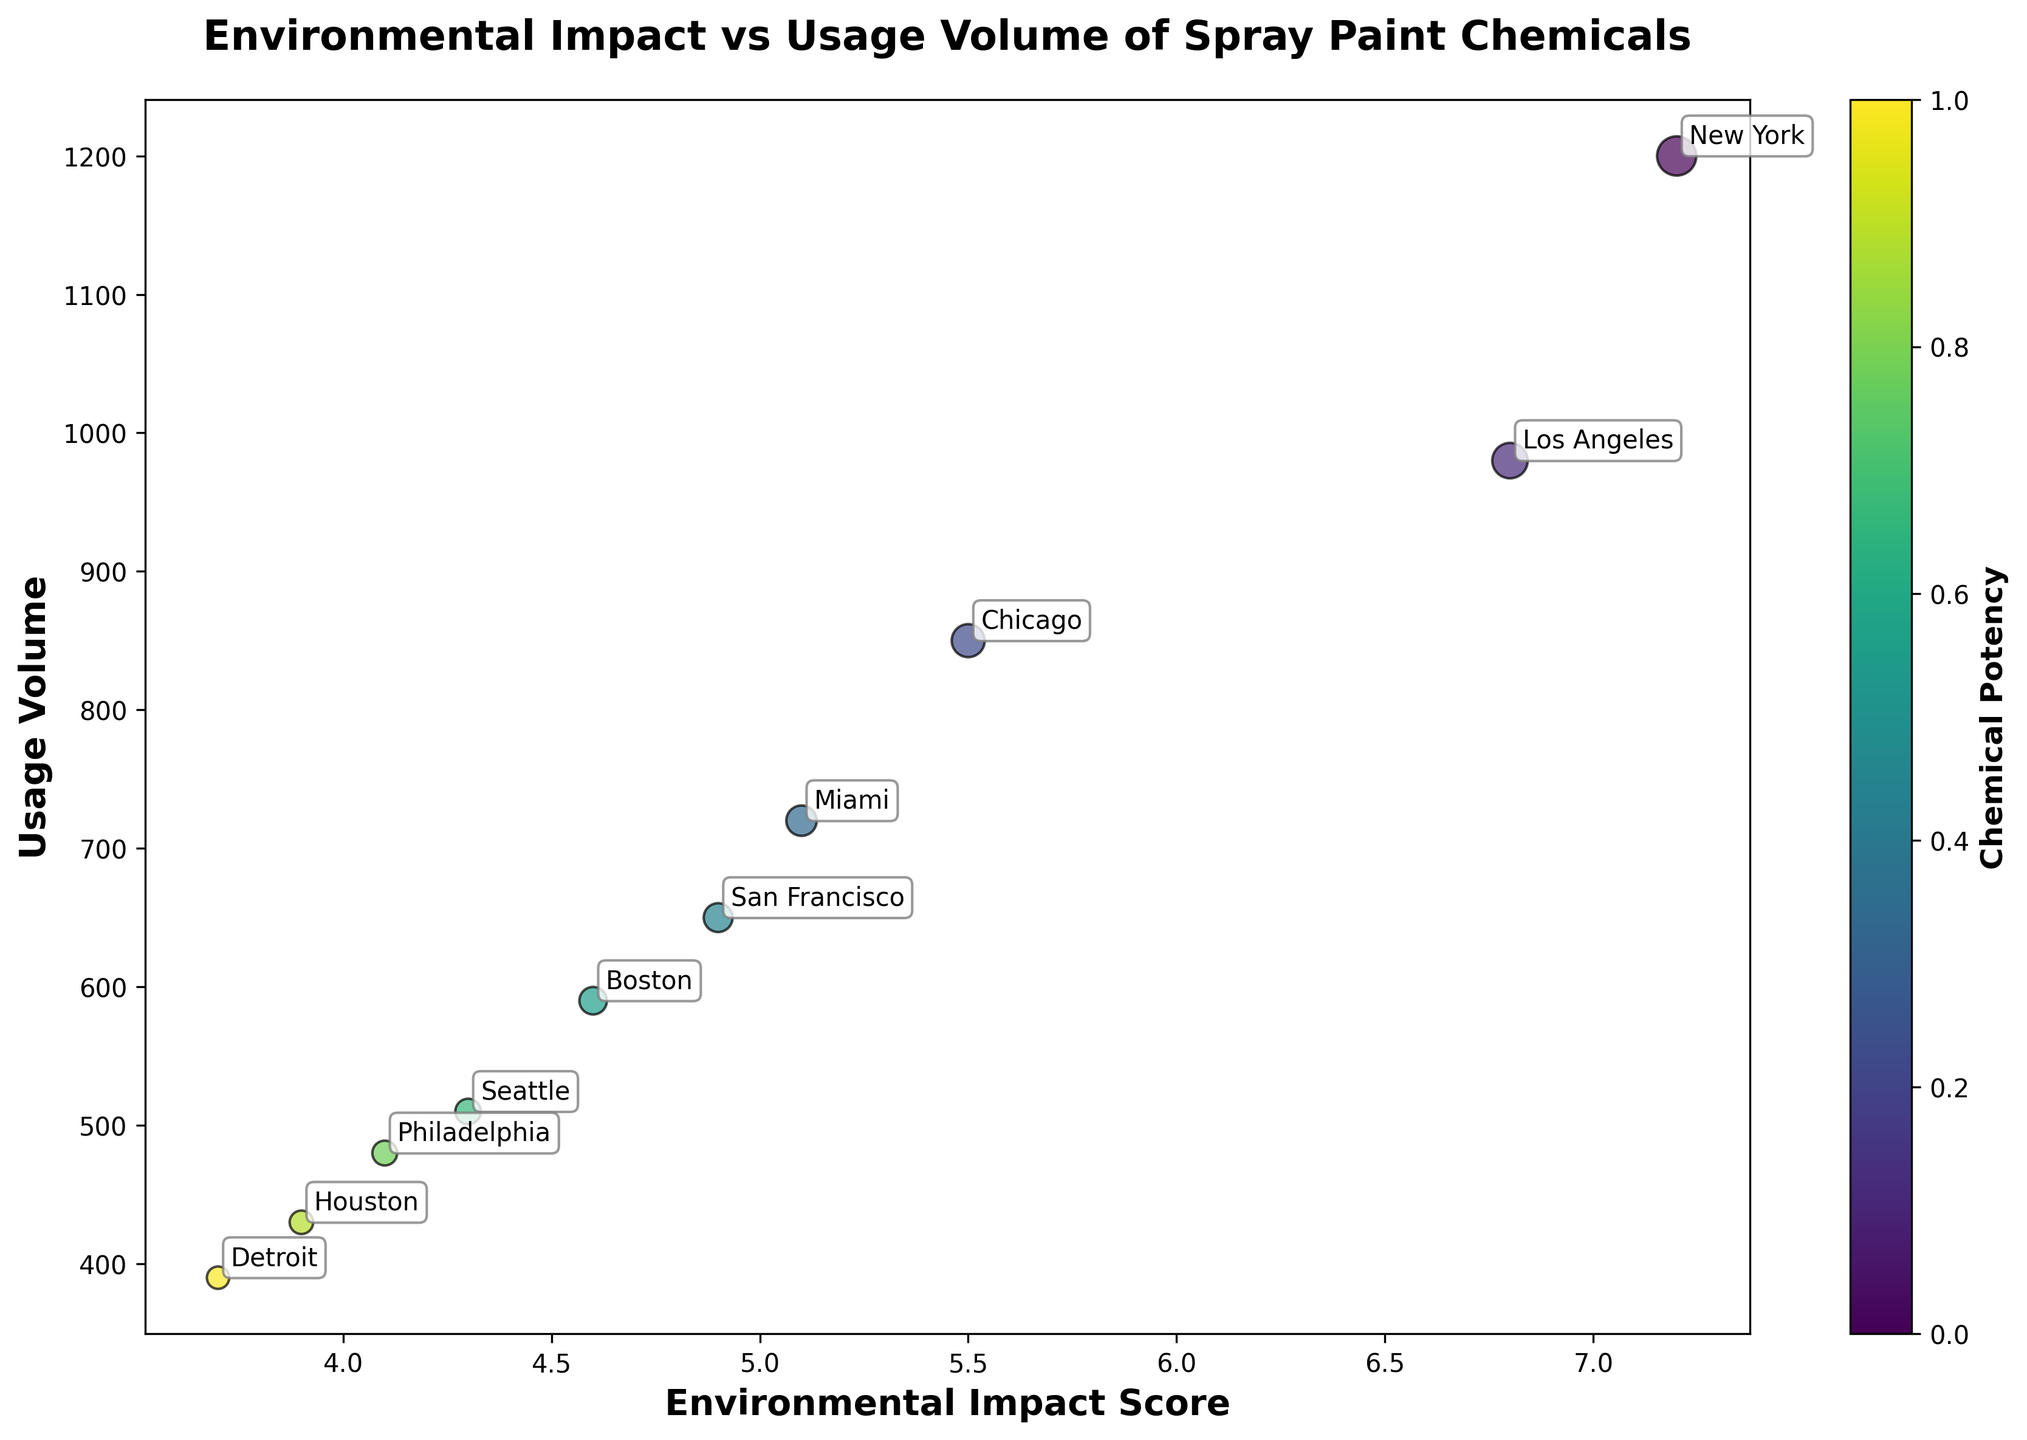What is the relationship between the Environmental Impact Score and Usage Volume shown in the plot? The scatter plot shows the relationship between the Environmental Impact Score and the Usage Volume of various chemicals. By observing the plot, larger bubbles represent higher Usage Volumes, and they tend to cluster around higher Impact Scores, indicating that chemicals with higher usage tend to have higher environmental impacts.
Answer: Positive relationship Which city corresponds to the chemical with the highest Environmental Impact Score? The chemical with the highest Environmental Impact Score appears to have a score of 7.2. From the plot, the bubble with this score is annotated as "New York".
Answer: New York What are the Environmental Impact Scores of the chemicals used in Chicago and Miami? By locating the annotations for "Chicago" and "Miami" and reading the corresponding Environmental Impact Scores from the x-axis, we see that Chicago’s score is 5.5, and Miami’s score is 5.1.
Answer: 5.5 (Chicago), 5.1 (Miami) Which city has the lowest Usage Volume, and what is that volume? The smallest bubble in the plot represents the lowest Usage Volume. The annotation for this bubble is "Detroit", and the volume is 390 (from the y-axis).
Answer: Detroit, 390 How many chemicals have an Environmental Impact Score greater than 5.0? By counting the number of bubbles to the right of the 5.0 mark on the x-axis, we find that there are 4 bubbles/cities in this area.
Answer: 4 Between which two cities is the largest difference in Usage Volume, and what is that difference? By comparing the Usage Volumes (Y-values) visually, New York has the highest volume (1200) and Detroit has the lowest volume (390). The difference is 1200 - 390 = 810.
Answer: New York and Detroit, 810 Which city’s chemical has an Impact Score of 4.6? By locating the bubble with an Impact Score of 4.6 on the x-axis and reading the corresponding city annotation, the city is "Boston".
Answer: Boston What is the median Environmental Impact Score of the chemicals shown in the plot? The Environmental Impact Scores are: 7.2, 6.8, 5.5, 5.1, 4.9, 4.6, 4.3, 4.1, 3.9, 3.7. The median is the middle value: (4.9 + 4.6)/2 = 4.75.
Answer: 4.75 Which city has a chemical with a Usage Volume closest to 500? By identifying the bubble closest to the y-axis value of 500, the city annotation is "Seattle" with a Usage Volume of 510.
Answer: Seattle 